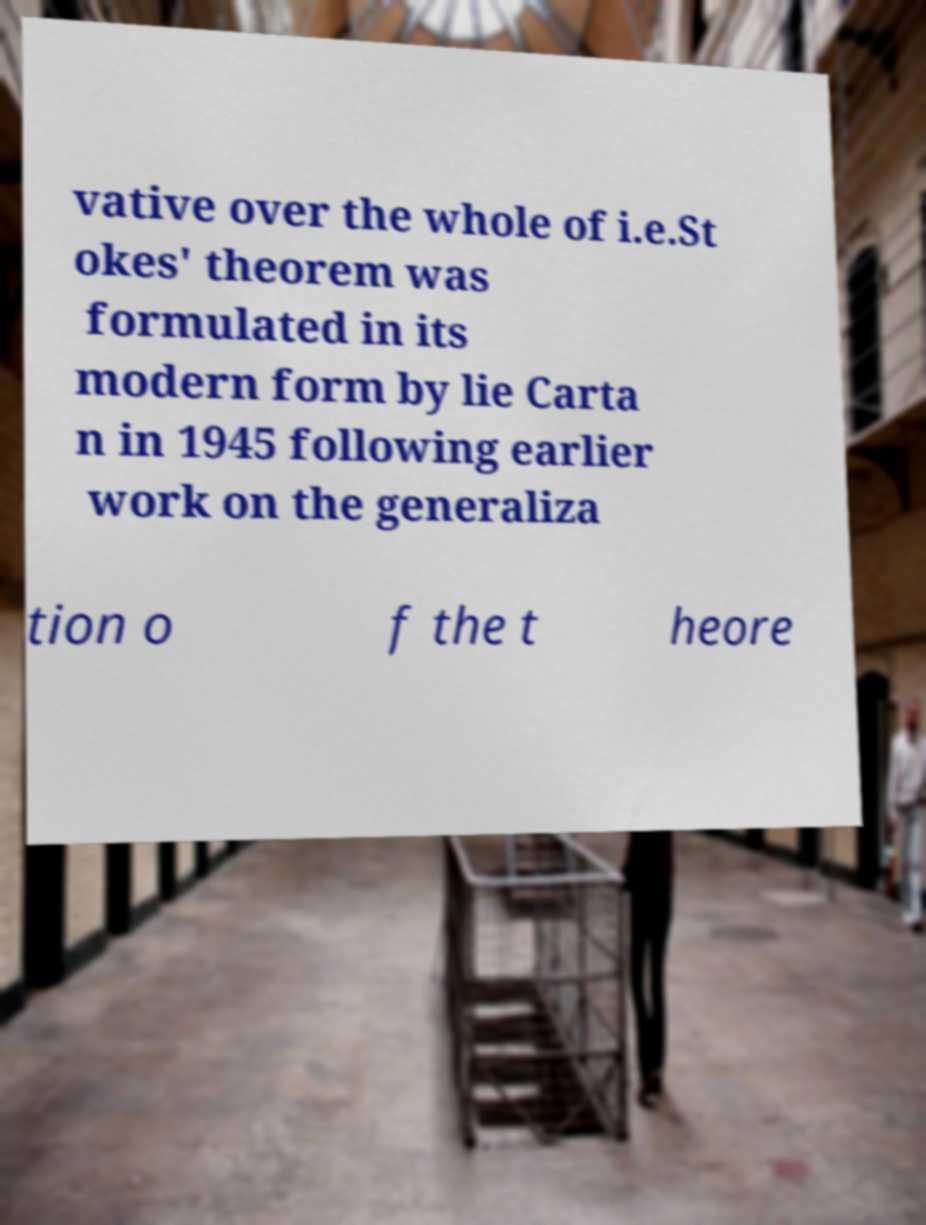For documentation purposes, I need the text within this image transcribed. Could you provide that? vative over the whole of i.e.St okes' theorem was formulated in its modern form by lie Carta n in 1945 following earlier work on the generaliza tion o f the t heore 